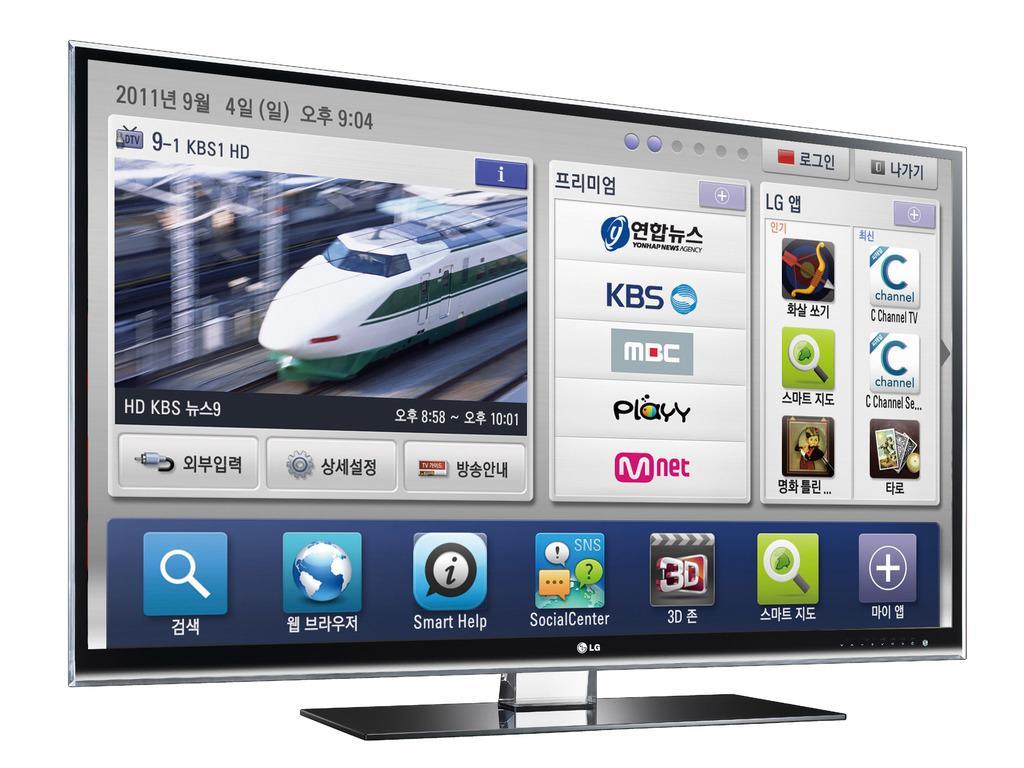In one or two sentences, can you explain what this image depicts? In this picture, there is a LG TV and there is some picture on this TV. 